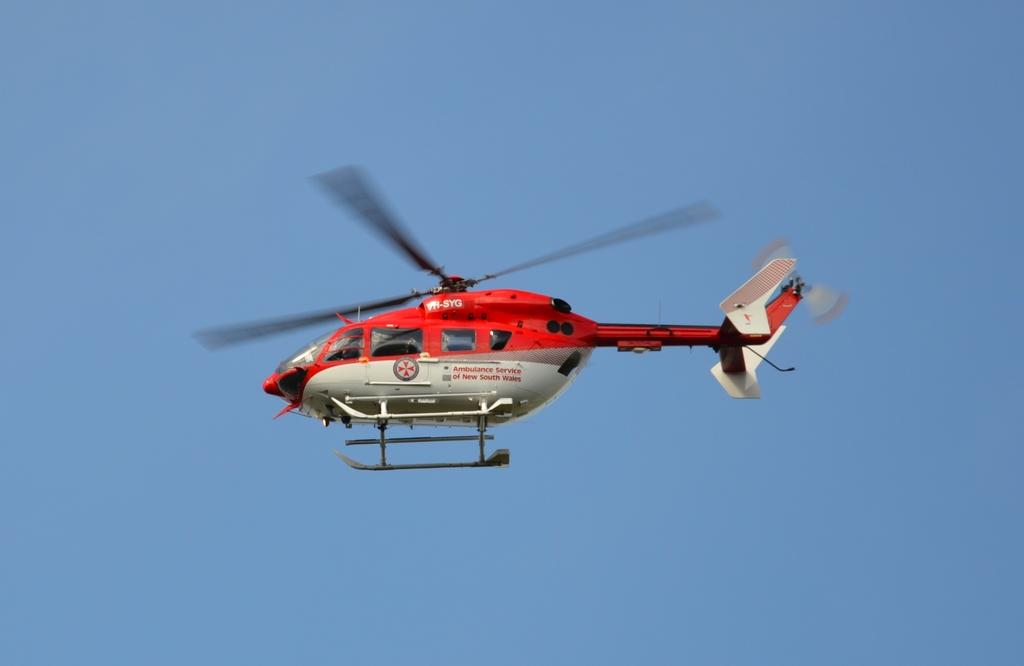What is the main subject of the image? The main subject of the image is a helicopter. What is the helicopter doing in the image? The helicopter is flying in the sky. How many sisters are visible in the image? There are no sisters present in the image; it features a helicopter flying in the sky. Can you touch the yam in the image? There is no yam present in the image, so it cannot be touched. 